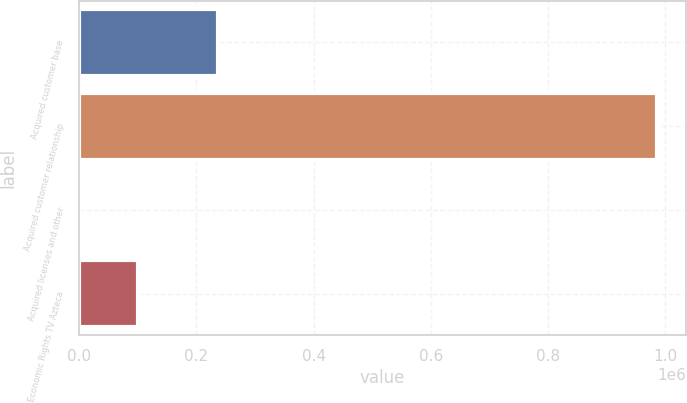Convert chart to OTSL. <chart><loc_0><loc_0><loc_500><loc_500><bar_chart><fcel>Acquired customer base<fcel>Acquired customer relationship<fcel>Acquired licenses and other<fcel>Economic Rights TV Azteca<nl><fcel>236881<fcel>985664<fcel>1617<fcel>100022<nl></chart> 